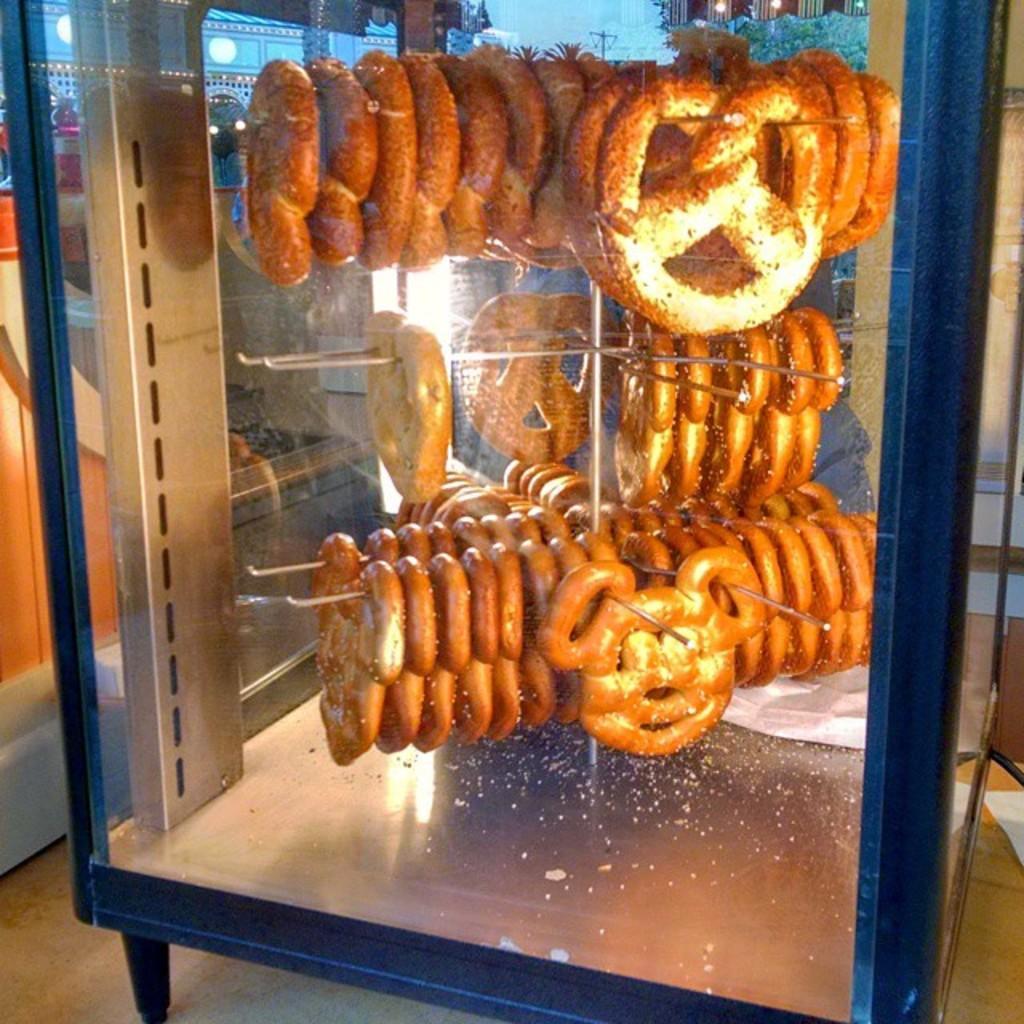Describe this image in one or two sentences. This image is taken indoors. At the bottom of the image there is a floor. In the background there is a wall. In the middle of the image there are a few food items in the box. 